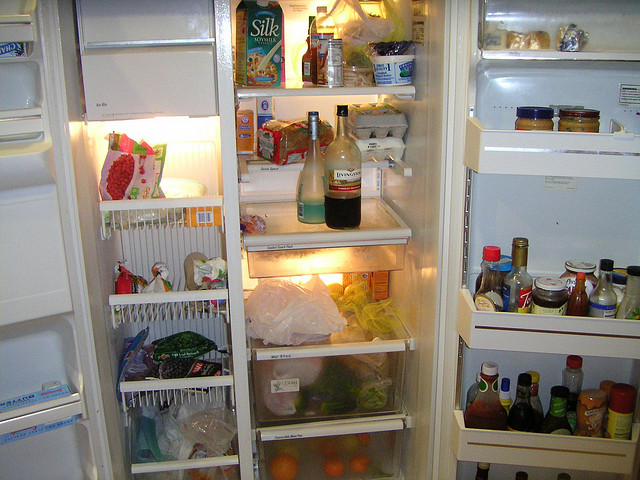Please identify all text content in this image. Silk T 